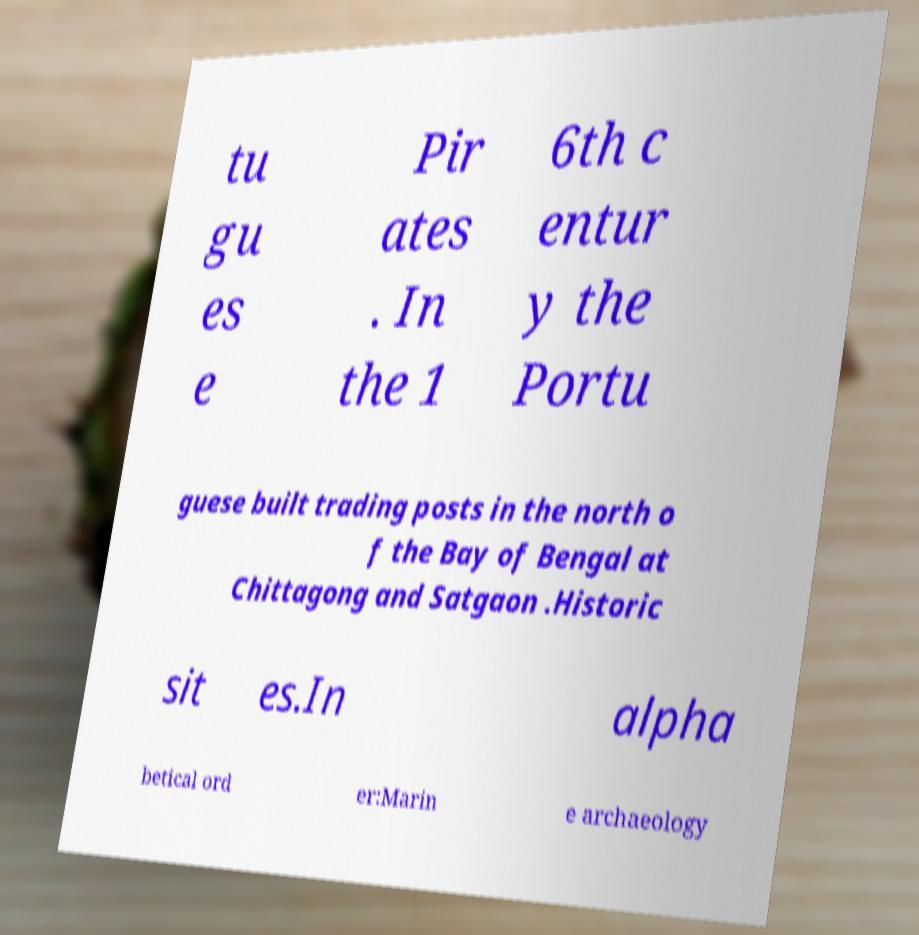Please read and relay the text visible in this image. What does it say? tu gu es e Pir ates . In the 1 6th c entur y the Portu guese built trading posts in the north o f the Bay of Bengal at Chittagong and Satgaon .Historic sit es.In alpha betical ord er:Marin e archaeology 